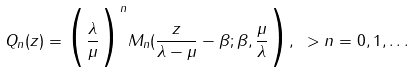Convert formula to latex. <formula><loc_0><loc_0><loc_500><loc_500>Q _ { n } ( z ) = \Big ( \frac { \lambda } { \mu } \Big ) ^ { n } M _ { n } ( \frac { z } { \lambda - \mu } - \beta ; \beta , \frac { \mu } { \lambda } \Big ) , \ > n = 0 , 1 , \dots</formula> 